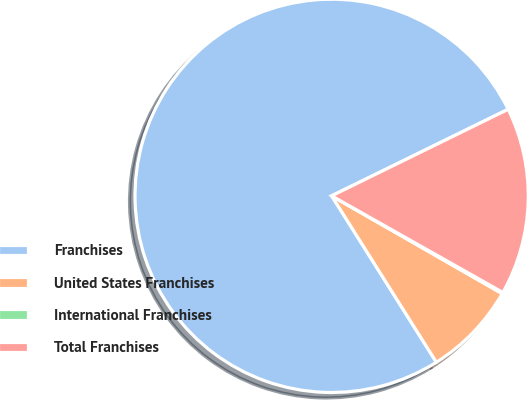Convert chart to OTSL. <chart><loc_0><loc_0><loc_500><loc_500><pie_chart><fcel>Franchises<fcel>United States Franchises<fcel>International Franchises<fcel>Total Franchises<nl><fcel>76.68%<fcel>7.77%<fcel>0.11%<fcel>15.43%<nl></chart> 